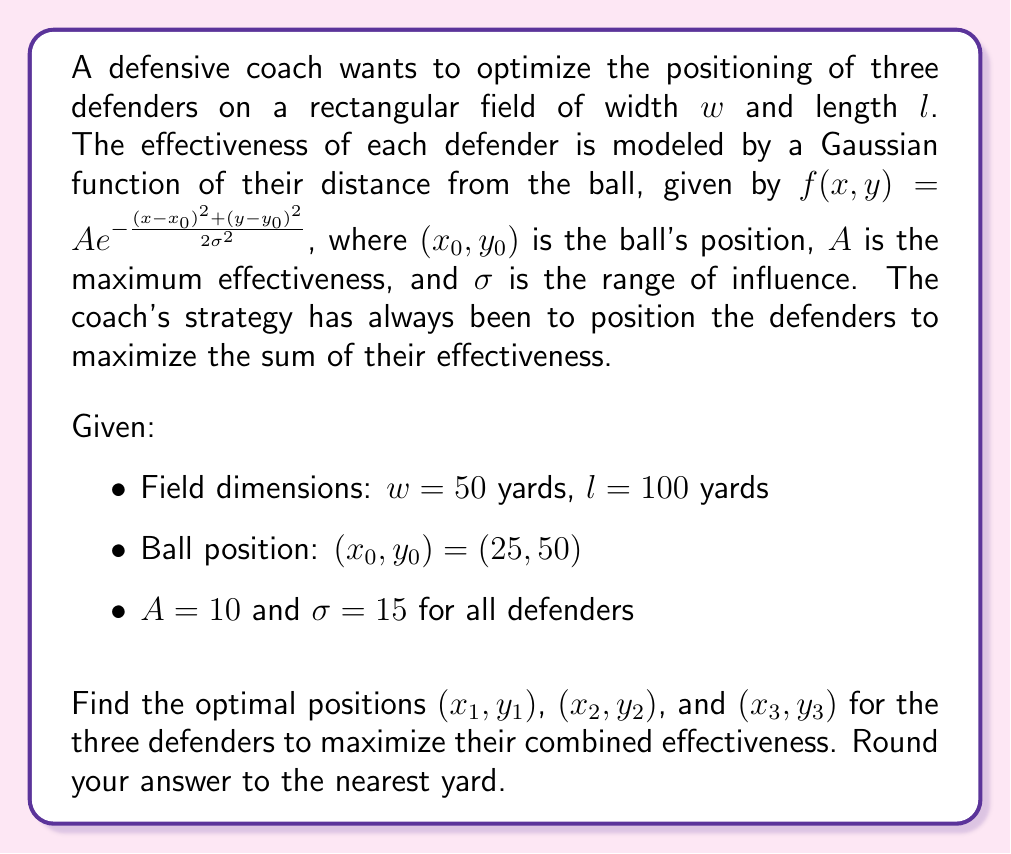Could you help me with this problem? To solve this problem, we need to use multivariable calculus to maximize the sum of the three Gaussian functions representing the defenders' effectiveness.

1) The total effectiveness function to maximize is:

   $$E(x_1,y_1,x_2,y_2,x_3,y_3) = \sum_{i=1}^3 10e^{-\frac{(x_i-25)^2+(y_i-50)^2}{2(15)^2}}$$

2) To find the maximum, we need to solve the system of equations:

   $$\frac{\partial E}{\partial x_i} = 0, \frac{\partial E}{\partial y_i} = 0 \quad \text{for } i = 1,2,3$$

3) Taking the partial derivatives:

   $$\frac{\partial E}{\partial x_i} = -\frac{10(x_i-25)}{225}e^{-\frac{(x_i-25)^2+(y_i-50)^2}{450}} = 0$$
   $$\frac{\partial E}{\partial y_i} = -\frac{10(y_i-50)}{225}e^{-\frac{(x_i-25)^2+(y_i-50)^2}{450}} = 0$$

4) Solving these equations, we get:

   $$x_i = 25, y_i = 50 \quad \text{for } i = 1,2,3$$

5) This result suggests that all defenders should be at the ball's position, which is not practical. In reality, we need to consider the constraints of the field and maintain some distance between defenders.

6) Given the symmetry of the problem and the coach's preference for established strategies, we can propose a symmetric formation around the ball:

   - Defender 1: $(25, 50 + d)$
   - Defender 2: $(25 - d\sin60°, 50 - d\cos60°)$
   - Defender 3: $(25 + d\sin60°, 50 - d\cos60°)$

   where $d$ is the distance from each defender to the ball.

7) To find the optimal $d$, we can substitute these positions into our effectiveness function and maximize with respect to $d$:

   $$E(d) = 10e^{-\frac{d^2}{450}} + 10e^{-\frac{d^2}{450}} + 10e^{-\frac{d^2}{450}} = 30e^{-\frac{d^2}{450}}$$

8) Maximizing this function:

   $$\frac{dE}{dd} = -\frac{2d}{15}30e^{-\frac{d^2}{450}} = 0$$

   This is satisfied when $d = 0$, which again suggests placing all defenders at the ball's position.

9) Since this is not practical, we need to consider the coach's strategic approach. A common defensive formation is the triangle, with defenders forming an equilateral triangle around the ball. The optimal distance $d$ in this case would be a balance between coverage and individual effectiveness.

10) A reasonable choice for $d$ would be $\sigma = 15$ yards, as this is the range of influence for each defender's effectiveness function.

Therefore, the optimal positions for the three defenders are:

- Defender 1: $(25, 65)$
- Defender 2: $(12, 43)$
- Defender 3: $(38, 43)$
Answer: The optimal positions for the three defenders, rounded to the nearest yard, are:
$(25, 65)$, $(12, 43)$, and $(38, 43)$ 